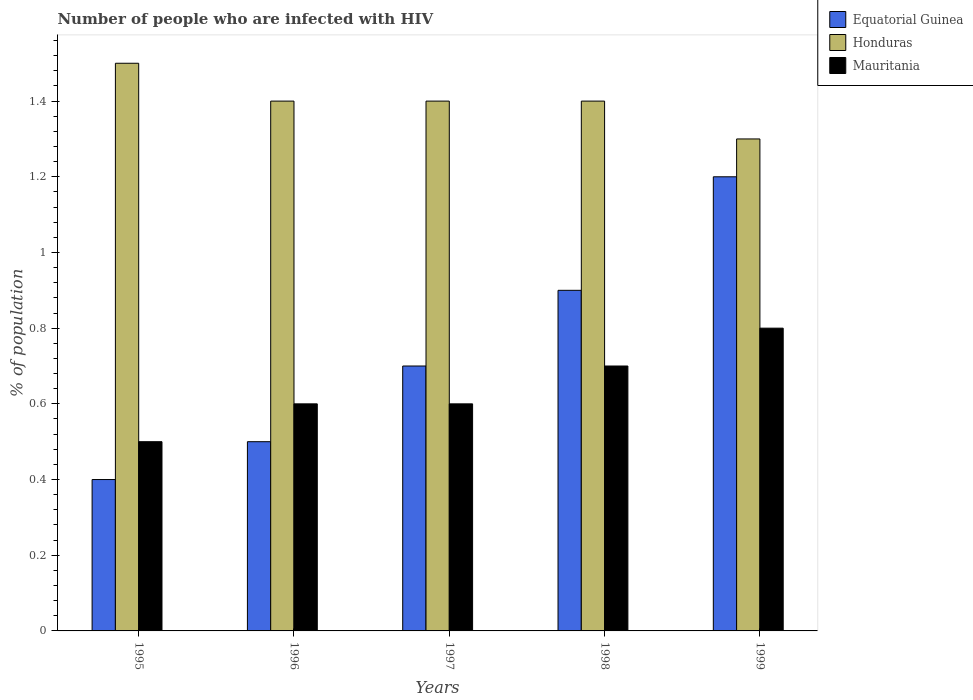How many different coloured bars are there?
Your answer should be very brief. 3. How many groups of bars are there?
Keep it short and to the point. 5. Are the number of bars on each tick of the X-axis equal?
Your answer should be very brief. Yes. What is the label of the 1st group of bars from the left?
Ensure brevity in your answer.  1995. In which year was the percentage of HIV infected population in in Honduras maximum?
Ensure brevity in your answer.  1995. What is the total percentage of HIV infected population in in Mauritania in the graph?
Your answer should be compact. 3.2. What is the difference between the percentage of HIV infected population in in Honduras in 1995 and that in 1996?
Your answer should be very brief. 0.1. What is the difference between the percentage of HIV infected population in in Equatorial Guinea in 1997 and the percentage of HIV infected population in in Mauritania in 1996?
Your response must be concise. 0.1. What is the average percentage of HIV infected population in in Equatorial Guinea per year?
Offer a very short reply. 0.74. In the year 1997, what is the difference between the percentage of HIV infected population in in Honduras and percentage of HIV infected population in in Mauritania?
Offer a terse response. 0.8. What is the ratio of the percentage of HIV infected population in in Equatorial Guinea in 1997 to that in 1999?
Make the answer very short. 0.58. Is the difference between the percentage of HIV infected population in in Honduras in 1995 and 1998 greater than the difference between the percentage of HIV infected population in in Mauritania in 1995 and 1998?
Ensure brevity in your answer.  Yes. What is the difference between the highest and the second highest percentage of HIV infected population in in Mauritania?
Keep it short and to the point. 0.1. What is the difference between the highest and the lowest percentage of HIV infected population in in Honduras?
Your response must be concise. 0.2. In how many years, is the percentage of HIV infected population in in Mauritania greater than the average percentage of HIV infected population in in Mauritania taken over all years?
Give a very brief answer. 2. What does the 1st bar from the left in 1995 represents?
Offer a very short reply. Equatorial Guinea. What does the 1st bar from the right in 1996 represents?
Provide a short and direct response. Mauritania. How many years are there in the graph?
Keep it short and to the point. 5. What is the difference between two consecutive major ticks on the Y-axis?
Your answer should be very brief. 0.2. Are the values on the major ticks of Y-axis written in scientific E-notation?
Offer a terse response. No. Does the graph contain any zero values?
Offer a very short reply. No. Does the graph contain grids?
Your response must be concise. No. Where does the legend appear in the graph?
Ensure brevity in your answer.  Top right. How are the legend labels stacked?
Provide a short and direct response. Vertical. What is the title of the graph?
Offer a very short reply. Number of people who are infected with HIV. Does "Cameroon" appear as one of the legend labels in the graph?
Provide a succinct answer. No. What is the label or title of the Y-axis?
Offer a terse response. % of population. What is the % of population in Honduras in 1995?
Your answer should be very brief. 1.5. What is the % of population of Equatorial Guinea in 1996?
Make the answer very short. 0.5. What is the % of population of Honduras in 1996?
Give a very brief answer. 1.4. What is the % of population of Mauritania in 1996?
Give a very brief answer. 0.6. What is the % of population in Equatorial Guinea in 1997?
Make the answer very short. 0.7. What is the % of population in Honduras in 1997?
Make the answer very short. 1.4. What is the % of population in Equatorial Guinea in 1998?
Offer a terse response. 0.9. What is the % of population of Honduras in 1998?
Your response must be concise. 1.4. What is the % of population of Mauritania in 1998?
Your answer should be compact. 0.7. Across all years, what is the maximum % of population of Equatorial Guinea?
Offer a terse response. 1.2. What is the total % of population in Equatorial Guinea in the graph?
Keep it short and to the point. 3.7. What is the difference between the % of population of Equatorial Guinea in 1995 and that in 1996?
Your response must be concise. -0.1. What is the difference between the % of population in Equatorial Guinea in 1995 and that in 1997?
Keep it short and to the point. -0.3. What is the difference between the % of population of Honduras in 1995 and that in 1997?
Keep it short and to the point. 0.1. What is the difference between the % of population of Mauritania in 1995 and that in 1997?
Your answer should be very brief. -0.1. What is the difference between the % of population of Equatorial Guinea in 1995 and that in 1998?
Provide a succinct answer. -0.5. What is the difference between the % of population of Equatorial Guinea in 1995 and that in 1999?
Give a very brief answer. -0.8. What is the difference between the % of population in Equatorial Guinea in 1996 and that in 1997?
Provide a succinct answer. -0.2. What is the difference between the % of population of Honduras in 1996 and that in 1997?
Your answer should be compact. 0. What is the difference between the % of population in Mauritania in 1996 and that in 1997?
Your response must be concise. 0. What is the difference between the % of population of Equatorial Guinea in 1996 and that in 1998?
Keep it short and to the point. -0.4. What is the difference between the % of population in Equatorial Guinea in 1996 and that in 1999?
Your answer should be very brief. -0.7. What is the difference between the % of population of Honduras in 1996 and that in 1999?
Offer a very short reply. 0.1. What is the difference between the % of population of Equatorial Guinea in 1997 and that in 1998?
Give a very brief answer. -0.2. What is the difference between the % of population in Honduras in 1997 and that in 1998?
Give a very brief answer. 0. What is the difference between the % of population of Honduras in 1997 and that in 1999?
Your answer should be very brief. 0.1. What is the difference between the % of population of Equatorial Guinea in 1998 and that in 1999?
Your answer should be compact. -0.3. What is the difference between the % of population in Mauritania in 1998 and that in 1999?
Ensure brevity in your answer.  -0.1. What is the difference between the % of population in Equatorial Guinea in 1995 and the % of population in Honduras in 1996?
Make the answer very short. -1. What is the difference between the % of population in Honduras in 1995 and the % of population in Mauritania in 1996?
Give a very brief answer. 0.9. What is the difference between the % of population of Equatorial Guinea in 1995 and the % of population of Honduras in 1997?
Your response must be concise. -1. What is the difference between the % of population of Equatorial Guinea in 1995 and the % of population of Mauritania in 1997?
Provide a short and direct response. -0.2. What is the difference between the % of population in Equatorial Guinea in 1995 and the % of population in Mauritania in 1998?
Offer a terse response. -0.3. What is the difference between the % of population in Honduras in 1995 and the % of population in Mauritania in 1998?
Give a very brief answer. 0.8. What is the difference between the % of population in Equatorial Guinea in 1995 and the % of population in Honduras in 1999?
Your answer should be compact. -0.9. What is the difference between the % of population in Equatorial Guinea in 1995 and the % of population in Mauritania in 1999?
Ensure brevity in your answer.  -0.4. What is the difference between the % of population in Equatorial Guinea in 1996 and the % of population in Honduras in 1997?
Provide a short and direct response. -0.9. What is the difference between the % of population in Equatorial Guinea in 1996 and the % of population in Mauritania in 1997?
Your answer should be very brief. -0.1. What is the difference between the % of population of Equatorial Guinea in 1996 and the % of population of Honduras in 1998?
Keep it short and to the point. -0.9. What is the difference between the % of population of Equatorial Guinea in 1996 and the % of population of Mauritania in 1998?
Keep it short and to the point. -0.2. What is the difference between the % of population in Equatorial Guinea in 1996 and the % of population in Honduras in 1999?
Offer a terse response. -0.8. What is the difference between the % of population of Equatorial Guinea in 1996 and the % of population of Mauritania in 1999?
Your answer should be compact. -0.3. What is the difference between the % of population in Honduras in 1996 and the % of population in Mauritania in 1999?
Provide a succinct answer. 0.6. What is the difference between the % of population in Equatorial Guinea in 1997 and the % of population in Mauritania in 1998?
Ensure brevity in your answer.  0. What is the difference between the % of population of Honduras in 1997 and the % of population of Mauritania in 1998?
Provide a succinct answer. 0.7. What is the difference between the % of population of Equatorial Guinea in 1997 and the % of population of Mauritania in 1999?
Your answer should be compact. -0.1. What is the difference between the % of population in Equatorial Guinea in 1998 and the % of population in Honduras in 1999?
Keep it short and to the point. -0.4. What is the difference between the % of population of Honduras in 1998 and the % of population of Mauritania in 1999?
Offer a terse response. 0.6. What is the average % of population of Equatorial Guinea per year?
Keep it short and to the point. 0.74. What is the average % of population in Honduras per year?
Make the answer very short. 1.4. What is the average % of population of Mauritania per year?
Give a very brief answer. 0.64. In the year 1995, what is the difference between the % of population in Equatorial Guinea and % of population in Honduras?
Provide a short and direct response. -1.1. In the year 1995, what is the difference between the % of population in Equatorial Guinea and % of population in Mauritania?
Keep it short and to the point. -0.1. In the year 1995, what is the difference between the % of population in Honduras and % of population in Mauritania?
Your answer should be compact. 1. In the year 1996, what is the difference between the % of population in Equatorial Guinea and % of population in Honduras?
Make the answer very short. -0.9. In the year 1996, what is the difference between the % of population in Honduras and % of population in Mauritania?
Your response must be concise. 0.8. In the year 1997, what is the difference between the % of population of Equatorial Guinea and % of population of Mauritania?
Offer a very short reply. 0.1. In the year 1998, what is the difference between the % of population of Equatorial Guinea and % of population of Honduras?
Provide a short and direct response. -0.5. In the year 1998, what is the difference between the % of population in Equatorial Guinea and % of population in Mauritania?
Make the answer very short. 0.2. In the year 1998, what is the difference between the % of population of Honduras and % of population of Mauritania?
Make the answer very short. 0.7. In the year 1999, what is the difference between the % of population in Equatorial Guinea and % of population in Mauritania?
Keep it short and to the point. 0.4. In the year 1999, what is the difference between the % of population of Honduras and % of population of Mauritania?
Your answer should be compact. 0.5. What is the ratio of the % of population of Equatorial Guinea in 1995 to that in 1996?
Make the answer very short. 0.8. What is the ratio of the % of population of Honduras in 1995 to that in 1996?
Your answer should be very brief. 1.07. What is the ratio of the % of population of Mauritania in 1995 to that in 1996?
Provide a succinct answer. 0.83. What is the ratio of the % of population of Honduras in 1995 to that in 1997?
Give a very brief answer. 1.07. What is the ratio of the % of population of Mauritania in 1995 to that in 1997?
Keep it short and to the point. 0.83. What is the ratio of the % of population in Equatorial Guinea in 1995 to that in 1998?
Provide a short and direct response. 0.44. What is the ratio of the % of population in Honduras in 1995 to that in 1998?
Offer a terse response. 1.07. What is the ratio of the % of population in Honduras in 1995 to that in 1999?
Offer a very short reply. 1.15. What is the ratio of the % of population of Equatorial Guinea in 1996 to that in 1998?
Offer a terse response. 0.56. What is the ratio of the % of population in Honduras in 1996 to that in 1998?
Your answer should be very brief. 1. What is the ratio of the % of population in Equatorial Guinea in 1996 to that in 1999?
Give a very brief answer. 0.42. What is the ratio of the % of population of Honduras in 1996 to that in 1999?
Give a very brief answer. 1.08. What is the ratio of the % of population of Equatorial Guinea in 1997 to that in 1998?
Your response must be concise. 0.78. What is the ratio of the % of population of Equatorial Guinea in 1997 to that in 1999?
Give a very brief answer. 0.58. What is the ratio of the % of population of Honduras in 1997 to that in 1999?
Offer a very short reply. 1.08. What is the ratio of the % of population in Mauritania in 1997 to that in 1999?
Provide a short and direct response. 0.75. What is the ratio of the % of population in Honduras in 1998 to that in 1999?
Make the answer very short. 1.08. What is the ratio of the % of population of Mauritania in 1998 to that in 1999?
Keep it short and to the point. 0.88. What is the difference between the highest and the second highest % of population in Equatorial Guinea?
Your answer should be very brief. 0.3. What is the difference between the highest and the second highest % of population of Mauritania?
Make the answer very short. 0.1. 